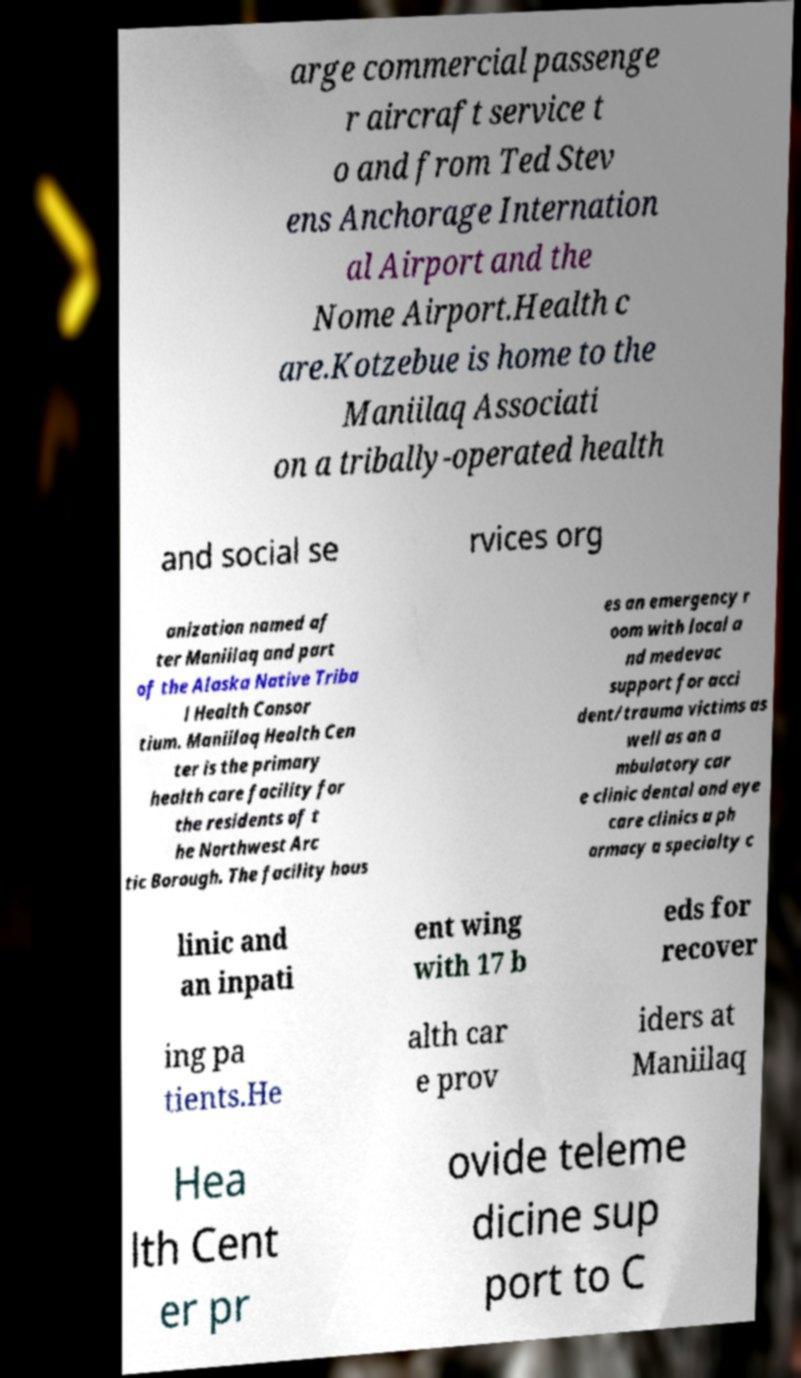For documentation purposes, I need the text within this image transcribed. Could you provide that? arge commercial passenge r aircraft service t o and from Ted Stev ens Anchorage Internation al Airport and the Nome Airport.Health c are.Kotzebue is home to the Maniilaq Associati on a tribally-operated health and social se rvices org anization named af ter Maniilaq and part of the Alaska Native Triba l Health Consor tium. Maniilaq Health Cen ter is the primary health care facility for the residents of t he Northwest Arc tic Borough. The facility hous es an emergency r oom with local a nd medevac support for acci dent/trauma victims as well as an a mbulatory car e clinic dental and eye care clinics a ph armacy a specialty c linic and an inpati ent wing with 17 b eds for recover ing pa tients.He alth car e prov iders at Maniilaq Hea lth Cent er pr ovide teleme dicine sup port to C 